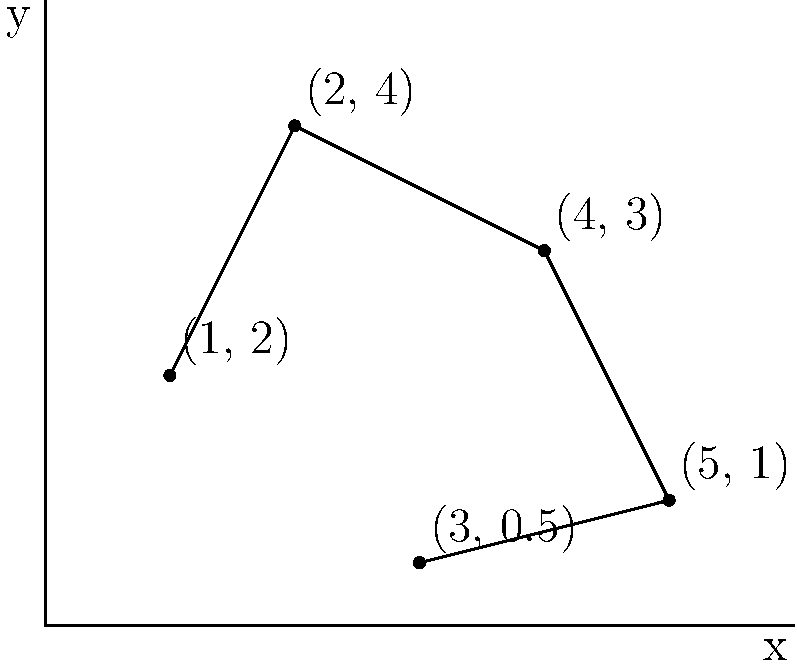The graph shows the success rates of five direct democracy initiatives in a small community. Each point represents an initiative, with the x-coordinate indicating the year (1 = 2019, 2 = 2020, etc.) and the y-coordinate representing the success rate as a decimal. Calculate the area of the polygon formed by connecting these data points in order. To find the area of the irregular polygon, we can use the Shoelace formula (also known as the surveyor's formula). The steps are as follows:

1) First, list the coordinates in order:
   $(1, 2)$, $(2, 4)$, $(4, 3)$, $(5, 1)$, $(3, 0.5)$

2) Apply the Shoelace formula:
   Area $= \frac{1}{2}|(x_1y_2 + x_2y_3 + ... + x_ny_1) - (y_1x_2 + y_2x_3 + ... + y_nx_1)|$

3) Calculate each term:
   $(1 \times 4) + (2 \times 3) + (4 \times 1) + (5 \times 0.5) + (3 \times 2) = 4 + 6 + 4 + 2.5 + 6 = 22.5$
   $(2 \times 2) + (4 \times 4) + (3 \times 5) + (1 \times 3) + (0.5 \times 1) = 4 + 16 + 15 + 3 + 0.5 = 38.5$

4) Subtract and take the absolute value:
   $|22.5 - 38.5| = 16$

5) Divide by 2:
   $\frac{16}{2} = 8$

Therefore, the area of the polygon is 8 square units.
Answer: 8 square units 